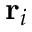<formula> <loc_0><loc_0><loc_500><loc_500>r _ { i }</formula> 